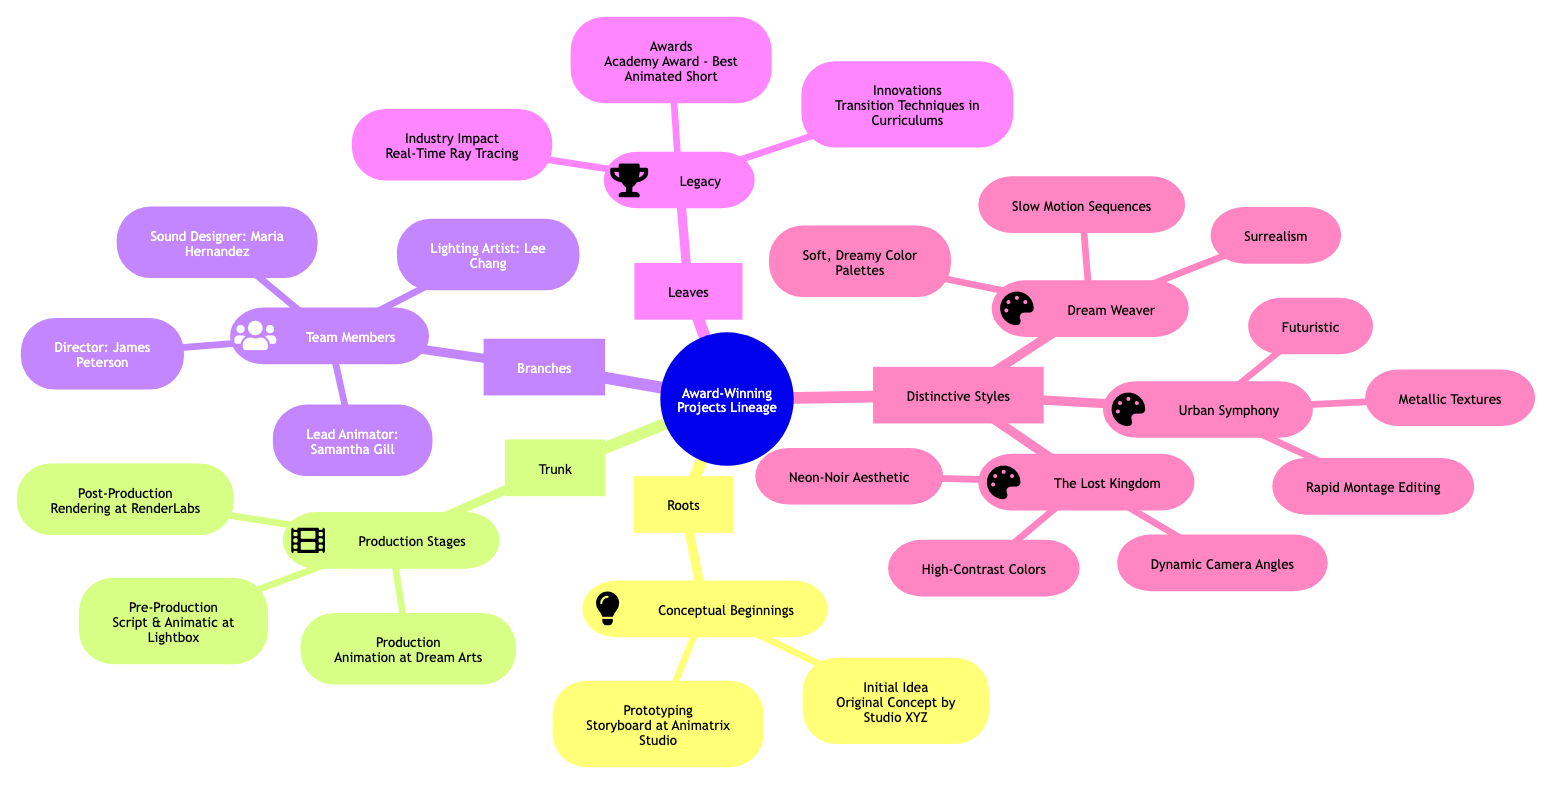What are the two elements under Conceptual Beginnings? The diagram shows two sub-elements branching from the Conceptual Beginnings category: "Initial Idea" and "Prototyping." These can be found directly under the label of the Conceptual Beginnings node.
Answer: Initial Idea, Prototyping Who was the Sound Designer in this project? In the Team Members category, the Sound Designer is specifically listed as "Maria Hernandez," which can be traced directly by locating the Team Members branch and reading its sub-elements.
Answer: Maria Hernandez What is the main industry impact associated with the legacy? The legacy section outlines one of its impacts as "Pioneering Use of Real-Time Ray Tracing," found within the Industry Impact sub-element of the Legacy node.
Answer: Pioneering Use of Real-Time Ray Tracing How many distinctive styles are represented in the diagram? The diagram lists three different projects within the Distinctive Styles category: "The Lost Kingdom," "Dream Weaver," and "Urban Symphony," resulting in a total count of three.
Answer: 3 What production stage occurs first according to the diagram? The Trunk section features the Production Stages element, which details Pre-Production as the first stage of the production process. This is confirmed by its top position in the list of stages.
Answer: Pre-Production Which project features a Surrealism style? Within the Distinctive Styles elements, "Dream Weaver" is explicitly associated with the Surrealism style as detailed in its specific sub-elements, indicating its distinctive artistic theme.
Answer: Dream Weaver How many team members are listed under Team Members? The diagram clearly indicates four team member roles: Director, Lead Animator, Lighting Artist, and Sound Designer, all of which can be counted directly within the Team Members category.
Answer: 4 Which project has a Neon-Noir Aesthetic? The project "The Lost Kingdom" is specifically associated with the Neon-Noir Aesthetic style, which is noted within its distinctive styles section.
Answer: The Lost Kingdom What type of award did the project win? Under the Legacy category, the awards sub-element specifies that the project received the "Academy Award for Best Animated Short," providing clear information about the accolades achieved.
Answer: Academy Award for Best Animated Short 